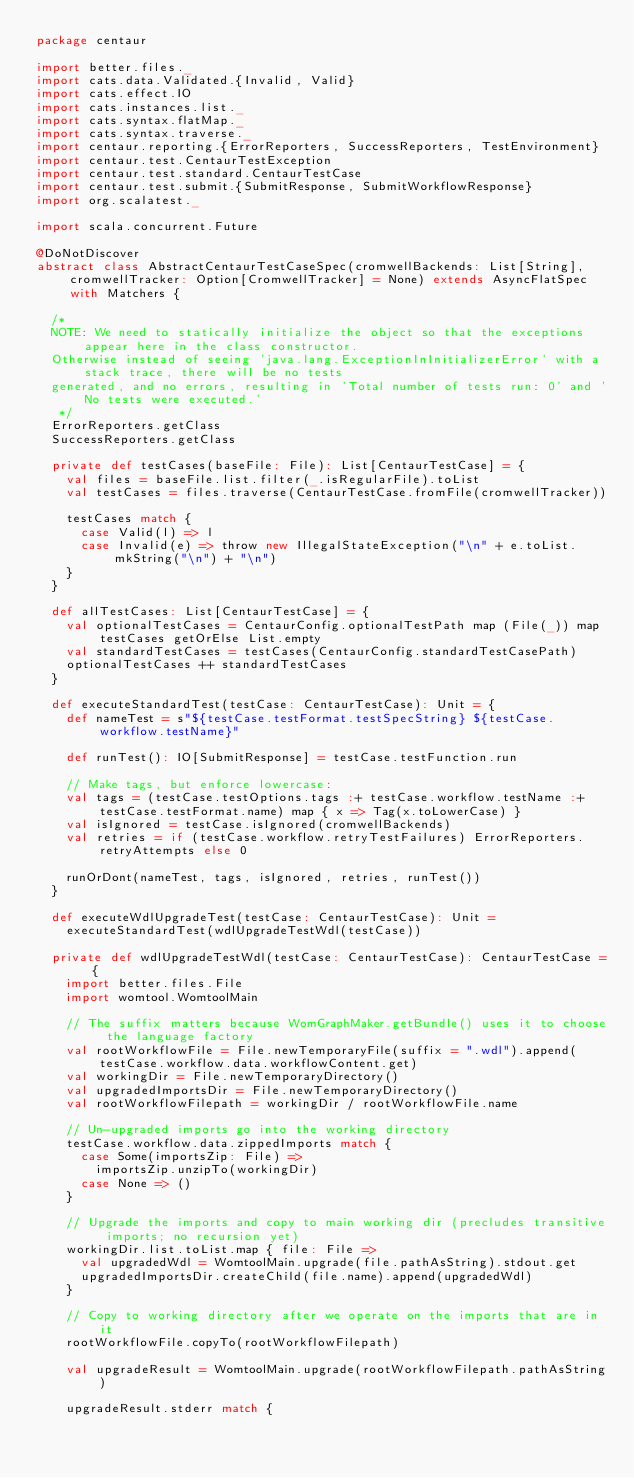<code> <loc_0><loc_0><loc_500><loc_500><_Scala_>package centaur

import better.files._
import cats.data.Validated.{Invalid, Valid}
import cats.effect.IO
import cats.instances.list._
import cats.syntax.flatMap._
import cats.syntax.traverse._
import centaur.reporting.{ErrorReporters, SuccessReporters, TestEnvironment}
import centaur.test.CentaurTestException
import centaur.test.standard.CentaurTestCase
import centaur.test.submit.{SubmitResponse, SubmitWorkflowResponse}
import org.scalatest._

import scala.concurrent.Future

@DoNotDiscover
abstract class AbstractCentaurTestCaseSpec(cromwellBackends: List[String], cromwellTracker: Option[CromwellTracker] = None) extends AsyncFlatSpec with Matchers {

  /*
  NOTE: We need to statically initialize the object so that the exceptions appear here in the class constructor.
  Otherwise instead of seeing 'java.lang.ExceptionInInitializerError' with a stack trace, there will be no tests
  generated, and no errors, resulting in 'Total number of tests run: 0' and 'No tests were executed.'
   */
  ErrorReporters.getClass
  SuccessReporters.getClass

  private def testCases(baseFile: File): List[CentaurTestCase] = {
    val files = baseFile.list.filter(_.isRegularFile).toList
    val testCases = files.traverse(CentaurTestCase.fromFile(cromwellTracker))

    testCases match {
      case Valid(l) => l
      case Invalid(e) => throw new IllegalStateException("\n" + e.toList.mkString("\n") + "\n")
    }
  }

  def allTestCases: List[CentaurTestCase] = {
    val optionalTestCases = CentaurConfig.optionalTestPath map (File(_)) map testCases getOrElse List.empty
    val standardTestCases = testCases(CentaurConfig.standardTestCasePath)
    optionalTestCases ++ standardTestCases
  }

  def executeStandardTest(testCase: CentaurTestCase): Unit = {
    def nameTest = s"${testCase.testFormat.testSpecString} ${testCase.workflow.testName}"

    def runTest(): IO[SubmitResponse] = testCase.testFunction.run

    // Make tags, but enforce lowercase:
    val tags = (testCase.testOptions.tags :+ testCase.workflow.testName :+ testCase.testFormat.name) map { x => Tag(x.toLowerCase) }
    val isIgnored = testCase.isIgnored(cromwellBackends)
    val retries = if (testCase.workflow.retryTestFailures) ErrorReporters.retryAttempts else 0

    runOrDont(nameTest, tags, isIgnored, retries, runTest())
  }

  def executeWdlUpgradeTest(testCase: CentaurTestCase): Unit =
    executeStandardTest(wdlUpgradeTestWdl(testCase))

  private def wdlUpgradeTestWdl(testCase: CentaurTestCase): CentaurTestCase = {
    import better.files.File
    import womtool.WomtoolMain

    // The suffix matters because WomGraphMaker.getBundle() uses it to choose the language factory
    val rootWorkflowFile = File.newTemporaryFile(suffix = ".wdl").append(testCase.workflow.data.workflowContent.get)
    val workingDir = File.newTemporaryDirectory()
    val upgradedImportsDir = File.newTemporaryDirectory()
    val rootWorkflowFilepath = workingDir / rootWorkflowFile.name

    // Un-upgraded imports go into the working directory
    testCase.workflow.data.zippedImports match {
      case Some(importsZip: File) =>
        importsZip.unzipTo(workingDir)
      case None => ()
    }

    // Upgrade the imports and copy to main working dir (precludes transitive imports; no recursion yet)
    workingDir.list.toList.map { file: File =>
      val upgradedWdl = WomtoolMain.upgrade(file.pathAsString).stdout.get
      upgradedImportsDir.createChild(file.name).append(upgradedWdl)
    }

    // Copy to working directory after we operate on the imports that are in it
    rootWorkflowFile.copyTo(rootWorkflowFilepath)

    val upgradeResult = WomtoolMain.upgrade(rootWorkflowFilepath.pathAsString)

    upgradeResult.stderr match {</code> 